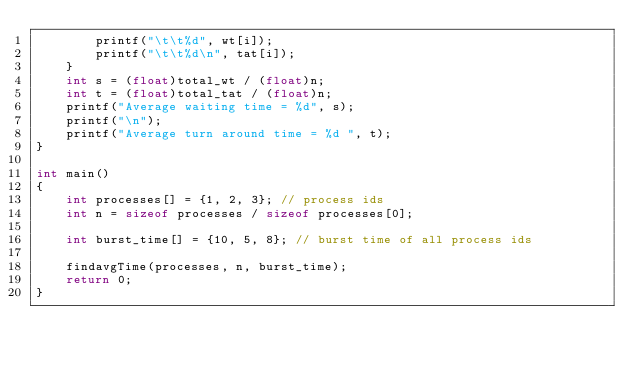Convert code to text. <code><loc_0><loc_0><loc_500><loc_500><_C_>        printf("\t\t%d", wt[i]);
        printf("\t\t%d\n", tat[i]);
    }
    int s = (float)total_wt / (float)n;
    int t = (float)total_tat / (float)n;
    printf("Average waiting time = %d", s);
    printf("\n");
    printf("Average turn around time = %d ", t);
}

int main()
{
    int processes[] = {1, 2, 3}; // process ids
    int n = sizeof processes / sizeof processes[0];

    int burst_time[] = {10, 5, 8}; // burst time of all process ids

    findavgTime(processes, n, burst_time);
    return 0;
}
</code> 